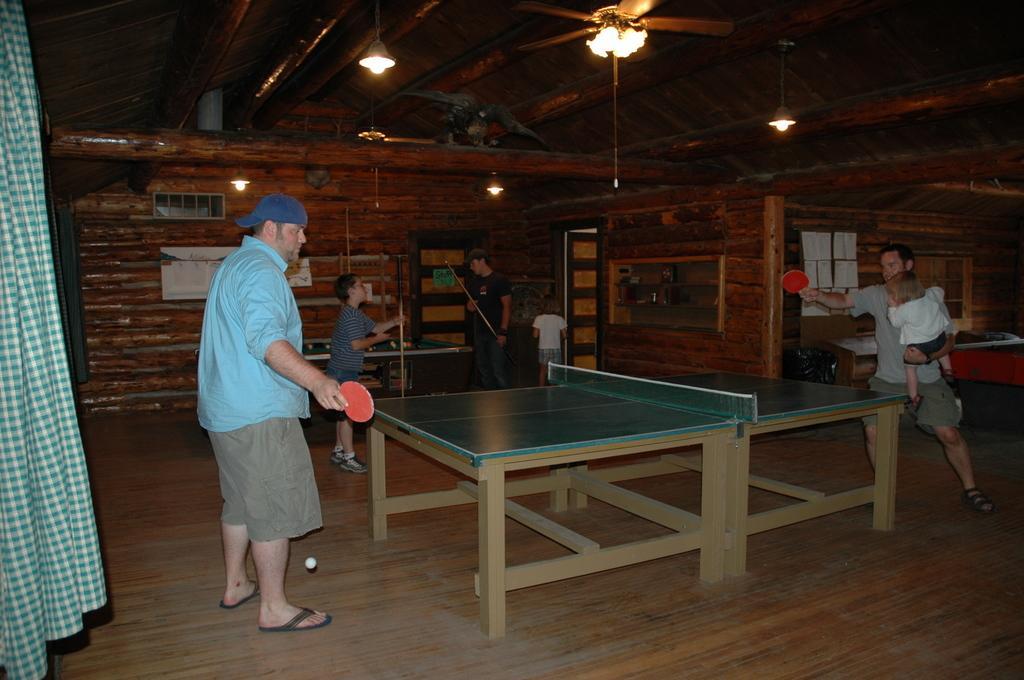Please provide a concise description of this image. This is a picture in a house, the two persons were playing the table tennis. The two persons were holding the bat on the roof there is a chandelier. Background of this is a wooden wall. 